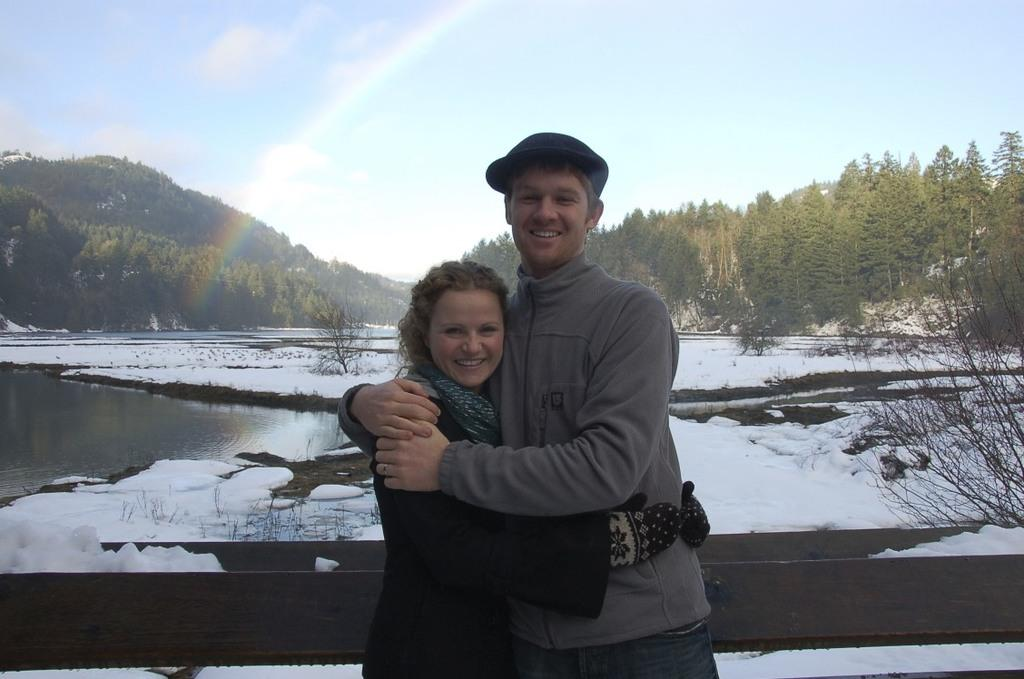How many people are in the image? There are two people standing in the image. What is one person wearing? One person is wearing a cap. What can be seen in the background of the image? There is a wooden fence, water, a group of trees, a rainbow, and a cloudy sky visible in the background of the image. What type of hole can be seen in the image? There is no hole present in the image. What does the image smell like? The image does not have a smell, as it is a visual representation. 